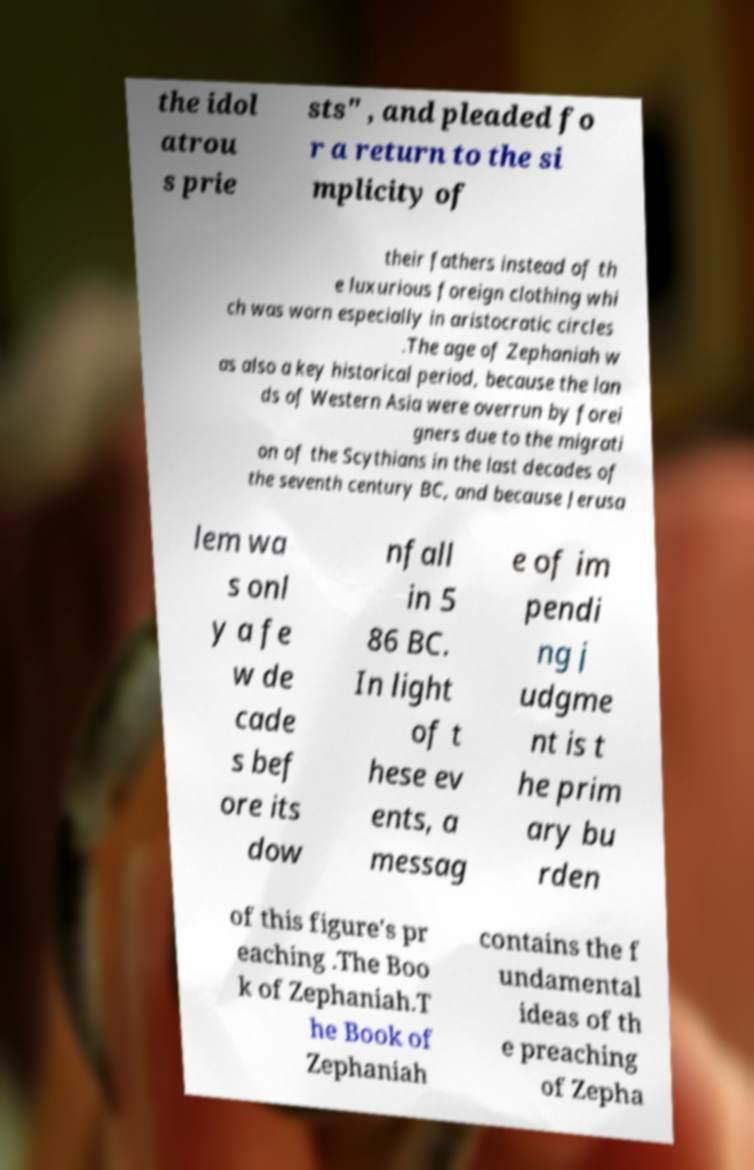Please identify and transcribe the text found in this image. the idol atrou s prie sts" , and pleaded fo r a return to the si mplicity of their fathers instead of th e luxurious foreign clothing whi ch was worn especially in aristocratic circles .The age of Zephaniah w as also a key historical period, because the lan ds of Western Asia were overrun by forei gners due to the migrati on of the Scythians in the last decades of the seventh century BC, and because Jerusa lem wa s onl y a fe w de cade s bef ore its dow nfall in 5 86 BC. In light of t hese ev ents, a messag e of im pendi ng j udgme nt is t he prim ary bu rden of this figure's pr eaching .The Boo k of Zephaniah.T he Book of Zephaniah contains the f undamental ideas of th e preaching of Zepha 